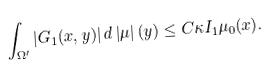<formula> <loc_0><loc_0><loc_500><loc_500>\int _ { \Omega ^ { \prime } } \left | G _ { 1 } ( x , y ) \right | d \left | \mu \right | ( y ) \leq C \kappa I _ { 1 } \mu _ { 0 } ( x ) .</formula> 